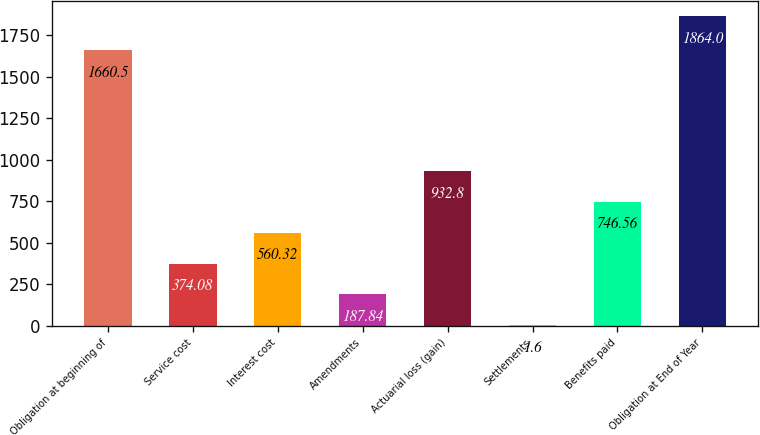<chart> <loc_0><loc_0><loc_500><loc_500><bar_chart><fcel>Obligation at beginning of<fcel>Service cost<fcel>Interest cost<fcel>Amendments<fcel>Actuarial loss (gain)<fcel>Settlements<fcel>Benefits paid<fcel>Obligation at End of Year<nl><fcel>1660.5<fcel>374.08<fcel>560.32<fcel>187.84<fcel>932.8<fcel>1.6<fcel>746.56<fcel>1864<nl></chart> 